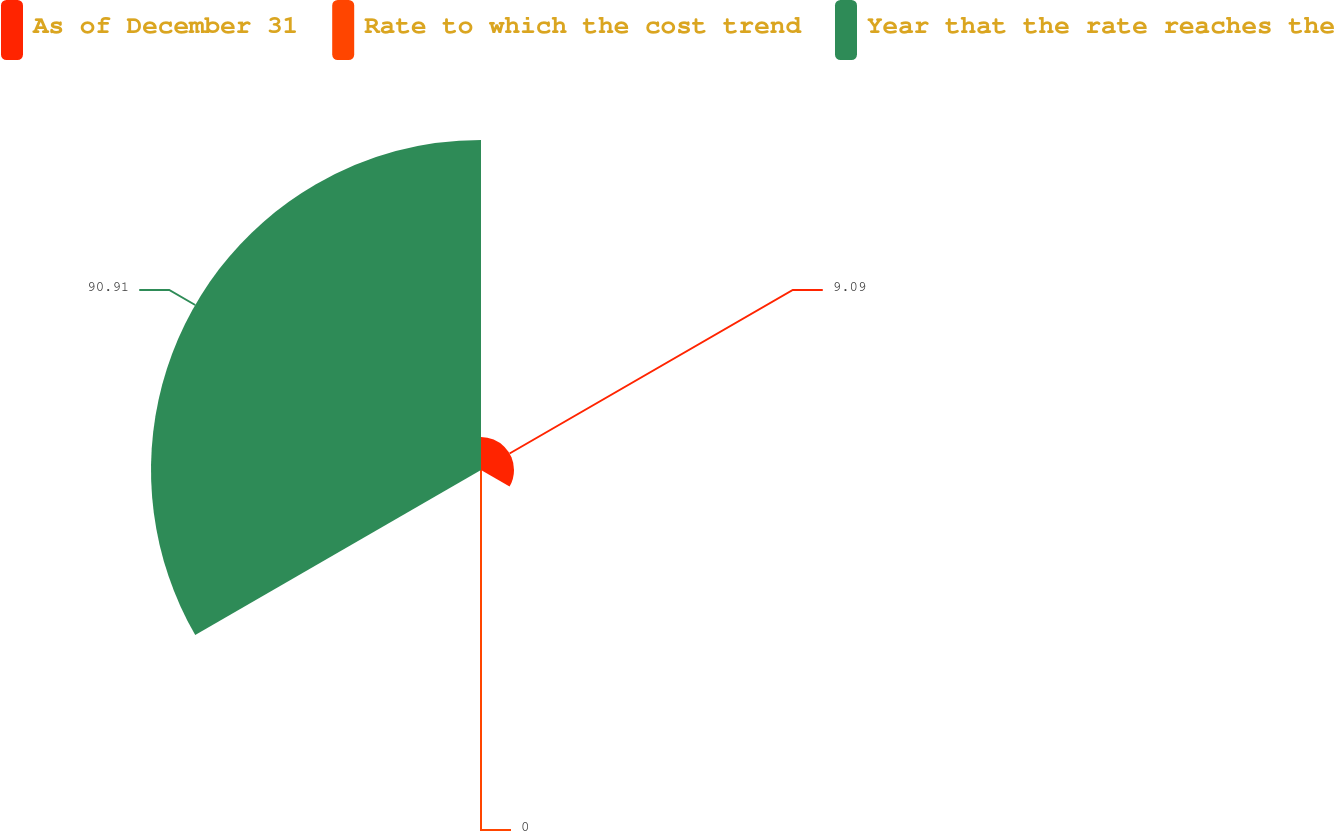Convert chart. <chart><loc_0><loc_0><loc_500><loc_500><pie_chart><fcel>As of December 31<fcel>Rate to which the cost trend<fcel>Year that the rate reaches the<nl><fcel>9.09%<fcel>0.0%<fcel>90.91%<nl></chart> 